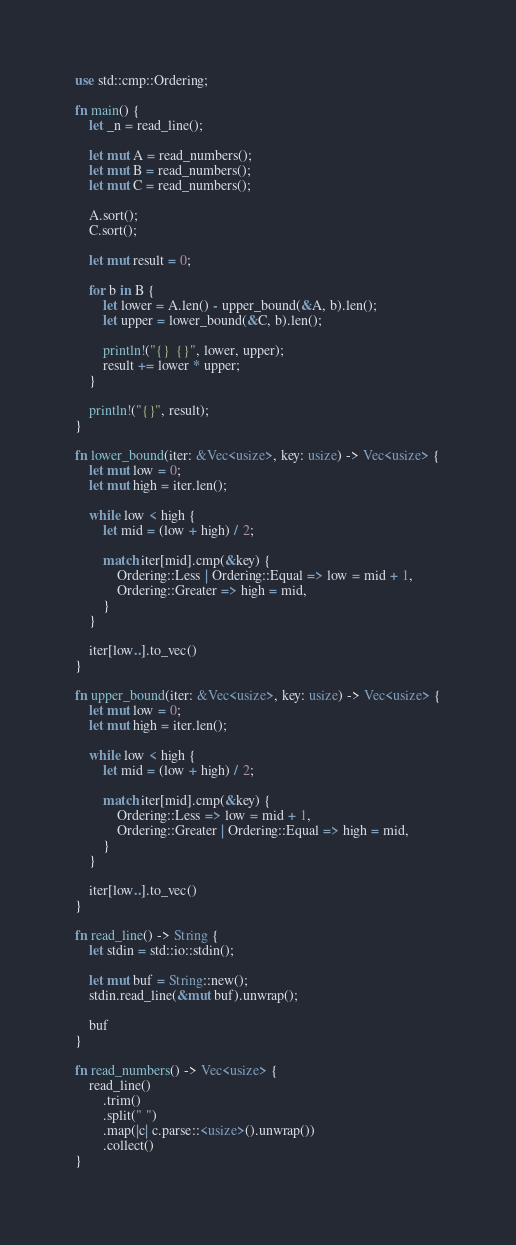Convert code to text. <code><loc_0><loc_0><loc_500><loc_500><_Rust_>use std::cmp::Ordering;

fn main() {
    let _n = read_line();

    let mut A = read_numbers();
    let mut B = read_numbers();
    let mut C = read_numbers();

    A.sort();
    C.sort();

    let mut result = 0;

    for b in B {
        let lower = A.len() - upper_bound(&A, b).len();
        let upper = lower_bound(&C, b).len();

        println!("{}  {}", lower, upper);
        result += lower * upper;
    }

    println!("{}", result);
}

fn lower_bound(iter: &Vec<usize>, key: usize) -> Vec<usize> {
    let mut low = 0;
    let mut high = iter.len();

    while low < high {
        let mid = (low + high) / 2;

        match iter[mid].cmp(&key) {
            Ordering::Less | Ordering::Equal => low = mid + 1,
            Ordering::Greater => high = mid,
        }
    }

    iter[low..].to_vec()
}

fn upper_bound(iter: &Vec<usize>, key: usize) -> Vec<usize> {
    let mut low = 0;
    let mut high = iter.len();

    while low < high {
        let mid = (low + high) / 2;

        match iter[mid].cmp(&key) {
            Ordering::Less => low = mid + 1,
            Ordering::Greater | Ordering::Equal => high = mid,
        }
    }

    iter[low..].to_vec()
}

fn read_line() -> String {
    let stdin = std::io::stdin();

    let mut buf = String::new();
    stdin.read_line(&mut buf).unwrap();

    buf
}

fn read_numbers() -> Vec<usize> {
    read_line()
        .trim()
        .split(" ")
        .map(|c| c.parse::<usize>().unwrap())
        .collect()
}</code> 